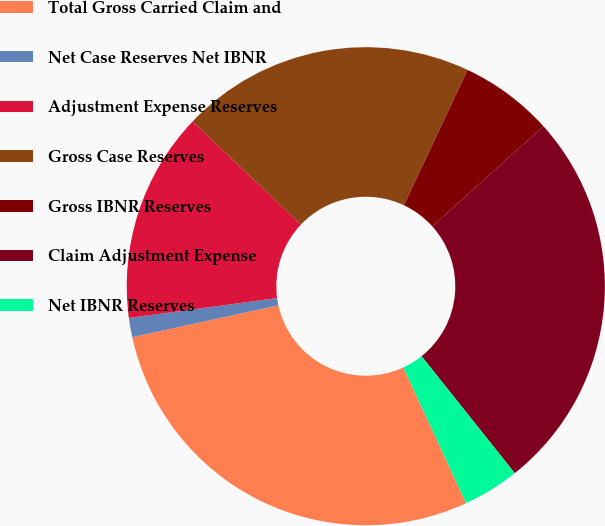<chart> <loc_0><loc_0><loc_500><loc_500><pie_chart><fcel>Total Gross Carried Claim and<fcel>Net Case Reserves Net IBNR<fcel>Adjustment Expense Reserves<fcel>Gross Case Reserves<fcel>Gross IBNR Reserves<fcel>Claim Adjustment Expense<fcel>Net IBNR Reserves<nl><fcel>28.47%<fcel>1.3%<fcel>14.22%<fcel>19.9%<fcel>6.33%<fcel>25.96%<fcel>3.82%<nl></chart> 